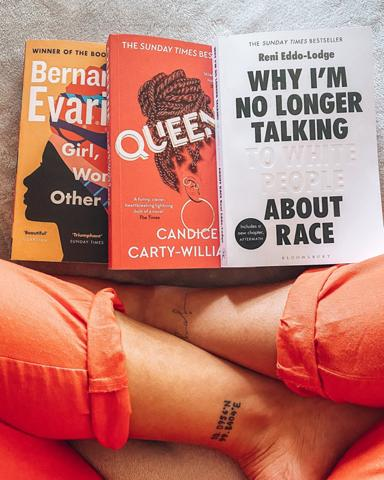How do the visual elements of the book covers contribute to the themes discussed within them? The striking covers of both books feature bold text and vibrant colors that grab attention. 'Queenie' uses an illustration that highlights the protagonist's dual heritage, reflecting the book's exploration of identity and belonging. 'Why I'm No Longer Talking To White People About Race' uses stark contrast in its cover design, symbolizing clarity and stark realities discussed within the book. 